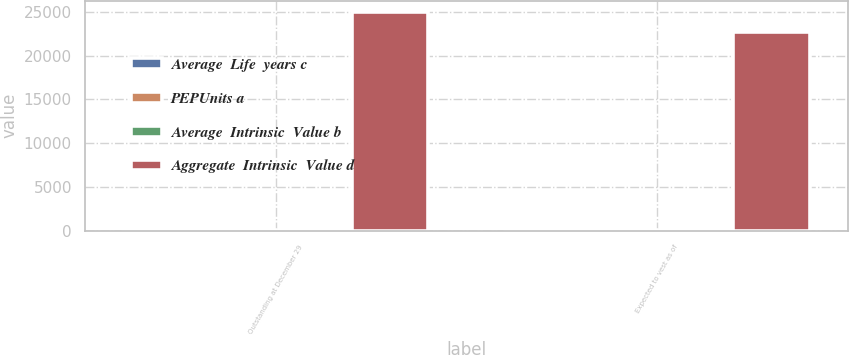Convert chart to OTSL. <chart><loc_0><loc_0><loc_500><loc_500><stacked_bar_chart><ecel><fcel>Outstanding at December 29<fcel>Expected to vest as of<nl><fcel>Average  Life  years c<fcel>368<fcel>334<nl><fcel>PEPUnits a<fcel>64.89<fcel>64.85<nl><fcel>Average  Intrinsic  Value b<fcel>2.26<fcel>2.26<nl><fcel>Aggregate  Intrinsic  Value d<fcel>25031<fcel>22721<nl></chart> 